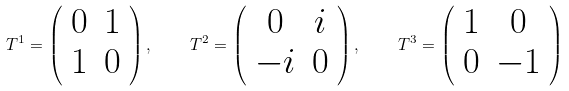Convert formula to latex. <formula><loc_0><loc_0><loc_500><loc_500>T ^ { 1 } = \left ( \begin{array} { c c } 0 & 1 \\ 1 & 0 \end{array} \right ) , \quad T ^ { 2 } = \left ( \begin{array} { c c } 0 & i \\ - i & 0 \end{array} \right ) , \quad T ^ { 3 } = \left ( \begin{array} { c c } 1 & 0 \\ 0 & - 1 \end{array} \right )</formula> 